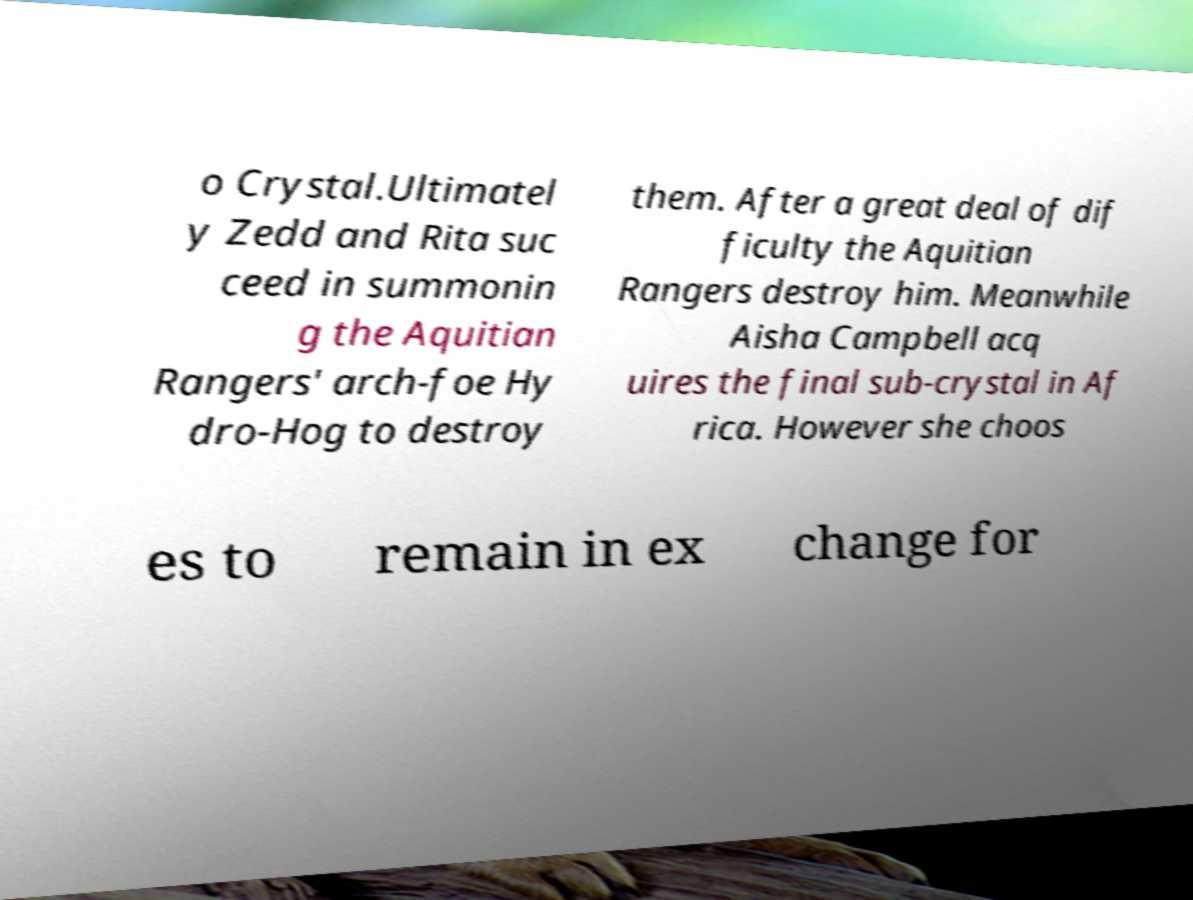Can you read and provide the text displayed in the image?This photo seems to have some interesting text. Can you extract and type it out for me? o Crystal.Ultimatel y Zedd and Rita suc ceed in summonin g the Aquitian Rangers' arch-foe Hy dro-Hog to destroy them. After a great deal of dif ficulty the Aquitian Rangers destroy him. Meanwhile Aisha Campbell acq uires the final sub-crystal in Af rica. However she choos es to remain in ex change for 